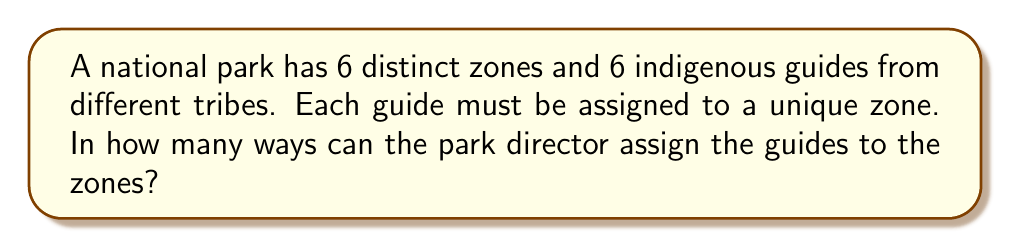Teach me how to tackle this problem. To solve this problem, we can use the concept of permutations. Here's the step-by-step explanation:

1) We have 6 guides and 6 zones, with each guide being assigned to exactly one zone and each zone receiving exactly one guide. This scenario is a perfect match for a permutation.

2) In permutations, the order matters (each specific assignment of a guide to a zone is considered unique), and we are using all the guides without repetition.

3) The formula for permutations of n distinct objects is:

   $$P(n) = n!$$

   Where $n!$ represents the factorial of n.

4) In this case, $n = 6$ (the number of guides or zones).

5) Therefore, the number of ways to assign the guides is:

   $$P(6) = 6!$$

6) Let's calculate 6!:
   
   $$6! = 6 \times 5 \times 4 \times 3 \times 2 \times 1 = 720$$

Thus, there are 720 unique ways to assign the 6 indigenous guides to the 6 park zones.
Answer: 720 